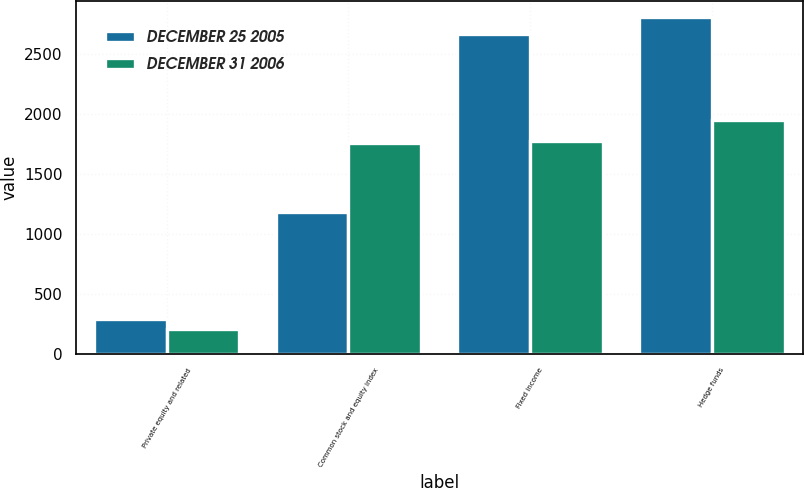Convert chart to OTSL. <chart><loc_0><loc_0><loc_500><loc_500><stacked_bar_chart><ecel><fcel>Private equity and related<fcel>Common stock and equity index<fcel>Fixed income<fcel>Hedge funds<nl><fcel>DECEMBER 25 2005<fcel>294<fcel>1179<fcel>2667<fcel>2802<nl><fcel>DECEMBER 31 2006<fcel>209<fcel>1757<fcel>1769<fcel>1945<nl></chart> 